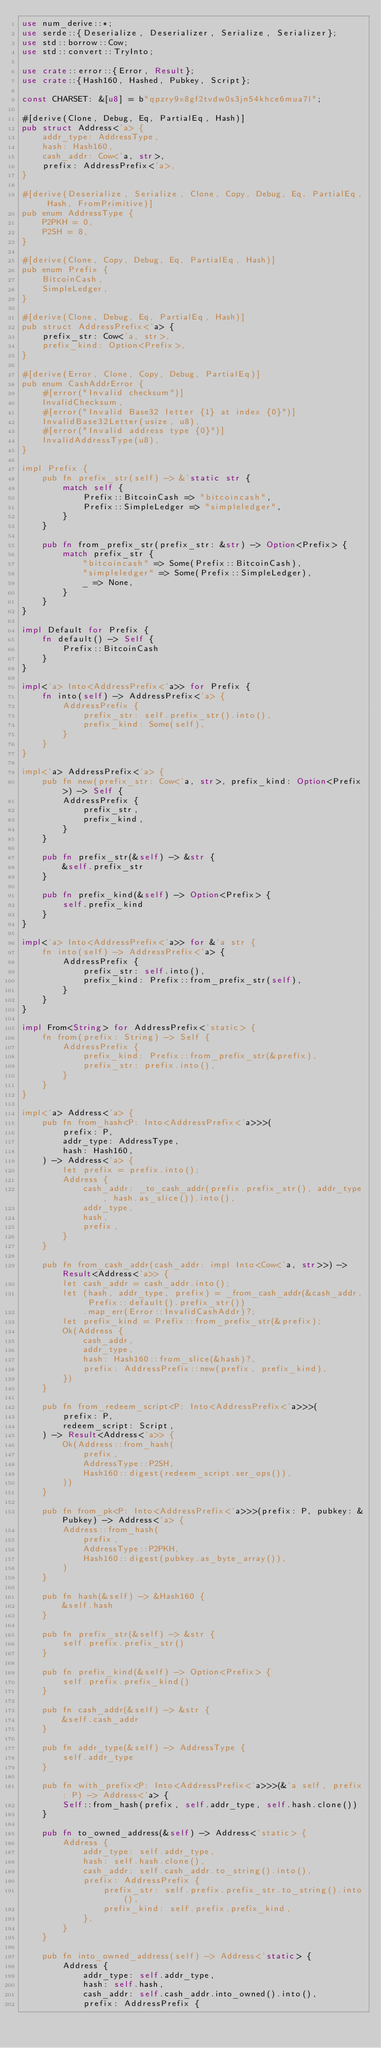Convert code to text. <code><loc_0><loc_0><loc_500><loc_500><_Rust_>use num_derive::*;
use serde::{Deserialize, Deserializer, Serialize, Serializer};
use std::borrow::Cow;
use std::convert::TryInto;

use crate::error::{Error, Result};
use crate::{Hash160, Hashed, Pubkey, Script};

const CHARSET: &[u8] = b"qpzry9x8gf2tvdw0s3jn54khce6mua7l";

#[derive(Clone, Debug, Eq, PartialEq, Hash)]
pub struct Address<'a> {
    addr_type: AddressType,
    hash: Hash160,
    cash_addr: Cow<'a, str>,
    prefix: AddressPrefix<'a>,
}

#[derive(Deserialize, Serialize, Clone, Copy, Debug, Eq, PartialEq, Hash, FromPrimitive)]
pub enum AddressType {
    P2PKH = 0,
    P2SH = 8,
}

#[derive(Clone, Copy, Debug, Eq, PartialEq, Hash)]
pub enum Prefix {
    BitcoinCash,
    SimpleLedger,
}

#[derive(Clone, Debug, Eq, PartialEq, Hash)]
pub struct AddressPrefix<'a> {
    prefix_str: Cow<'a, str>,
    prefix_kind: Option<Prefix>,
}

#[derive(Error, Clone, Copy, Debug, PartialEq)]
pub enum CashAddrError {
    #[error("Invalid checksum")]
    InvalidChecksum,
    #[error("Invalid Base32 letter {1} at index {0}")]
    InvalidBase32Letter(usize, u8),
    #[error("Invalid address type {0}")]
    InvalidAddressType(u8),
}

impl Prefix {
    pub fn prefix_str(self) -> &'static str {
        match self {
            Prefix::BitcoinCash => "bitcoincash",
            Prefix::SimpleLedger => "simpleledger",
        }
    }

    pub fn from_prefix_str(prefix_str: &str) -> Option<Prefix> {
        match prefix_str {
            "bitcoincash" => Some(Prefix::BitcoinCash),
            "simpleledger" => Some(Prefix::SimpleLedger),
            _ => None,
        }
    }
}

impl Default for Prefix {
    fn default() -> Self {
        Prefix::BitcoinCash
    }
}

impl<'a> Into<AddressPrefix<'a>> for Prefix {
    fn into(self) -> AddressPrefix<'a> {
        AddressPrefix {
            prefix_str: self.prefix_str().into(),
            prefix_kind: Some(self),
        }
    }
}

impl<'a> AddressPrefix<'a> {
    pub fn new(prefix_str: Cow<'a, str>, prefix_kind: Option<Prefix>) -> Self {
        AddressPrefix {
            prefix_str,
            prefix_kind,
        }
    }

    pub fn prefix_str(&self) -> &str {
        &self.prefix_str
    }

    pub fn prefix_kind(&self) -> Option<Prefix> {
        self.prefix_kind
    }
}

impl<'a> Into<AddressPrefix<'a>> for &'a str {
    fn into(self) -> AddressPrefix<'a> {
        AddressPrefix {
            prefix_str: self.into(),
            prefix_kind: Prefix::from_prefix_str(self),
        }
    }
}

impl From<String> for AddressPrefix<'static> {
    fn from(prefix: String) -> Self {
        AddressPrefix {
            prefix_kind: Prefix::from_prefix_str(&prefix),
            prefix_str: prefix.into(),
        }
    }
}

impl<'a> Address<'a> {
    pub fn from_hash<P: Into<AddressPrefix<'a>>>(
        prefix: P,
        addr_type: AddressType,
        hash: Hash160,
    ) -> Address<'a> {
        let prefix = prefix.into();
        Address {
            cash_addr: _to_cash_addr(prefix.prefix_str(), addr_type, hash.as_slice()).into(),
            addr_type,
            hash,
            prefix,
        }
    }

    pub fn from_cash_addr(cash_addr: impl Into<Cow<'a, str>>) -> Result<Address<'a>> {
        let cash_addr = cash_addr.into();
        let (hash, addr_type, prefix) = _from_cash_addr(&cash_addr, Prefix::default().prefix_str())
            .map_err(Error::InvalidCashAddr)?;
        let prefix_kind = Prefix::from_prefix_str(&prefix);
        Ok(Address {
            cash_addr,
            addr_type,
            hash: Hash160::from_slice(&hash)?,
            prefix: AddressPrefix::new(prefix, prefix_kind),
        })
    }

    pub fn from_redeem_script<P: Into<AddressPrefix<'a>>>(
        prefix: P,
        redeem_script: Script,
    ) -> Result<Address<'a>> {
        Ok(Address::from_hash(
            prefix,
            AddressType::P2SH,
            Hash160::digest(redeem_script.ser_ops()),
        ))
    }

    pub fn from_pk<P: Into<AddressPrefix<'a>>>(prefix: P, pubkey: &Pubkey) -> Address<'a> {
        Address::from_hash(
            prefix,
            AddressType::P2PKH,
            Hash160::digest(pubkey.as_byte_array()),
        )
    }

    pub fn hash(&self) -> &Hash160 {
        &self.hash
    }

    pub fn prefix_str(&self) -> &str {
        self.prefix.prefix_str()
    }

    pub fn prefix_kind(&self) -> Option<Prefix> {
        self.prefix.prefix_kind()
    }

    pub fn cash_addr(&self) -> &str {
        &self.cash_addr
    }

    pub fn addr_type(&self) -> AddressType {
        self.addr_type
    }

    pub fn with_prefix<P: Into<AddressPrefix<'a>>>(&'a self, prefix: P) -> Address<'a> {
        Self::from_hash(prefix, self.addr_type, self.hash.clone())
    }

    pub fn to_owned_address(&self) -> Address<'static> {
        Address {
            addr_type: self.addr_type,
            hash: self.hash.clone(),
            cash_addr: self.cash_addr.to_string().into(),
            prefix: AddressPrefix {
                prefix_str: self.prefix.prefix_str.to_string().into(),
                prefix_kind: self.prefix.prefix_kind,
            },
        }
    }

    pub fn into_owned_address(self) -> Address<'static> {
        Address {
            addr_type: self.addr_type,
            hash: self.hash,
            cash_addr: self.cash_addr.into_owned().into(),
            prefix: AddressPrefix {</code> 